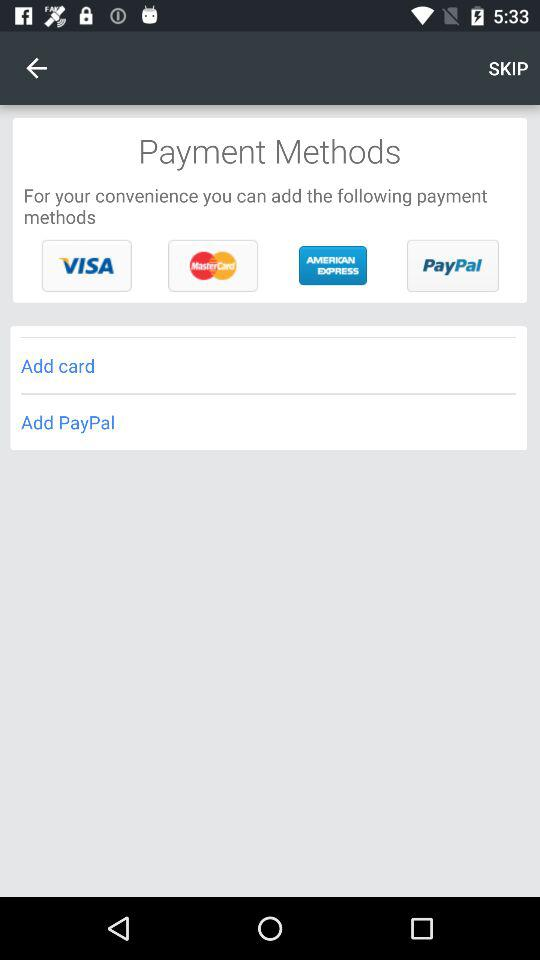How many payment methods are available?
Answer the question using a single word or phrase. 4 